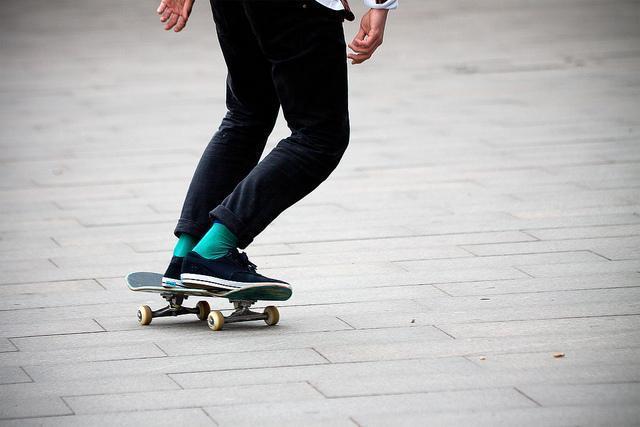How many wheels are shown?
Give a very brief answer. 4. How many coca-cola bottles are there?
Give a very brief answer. 0. 